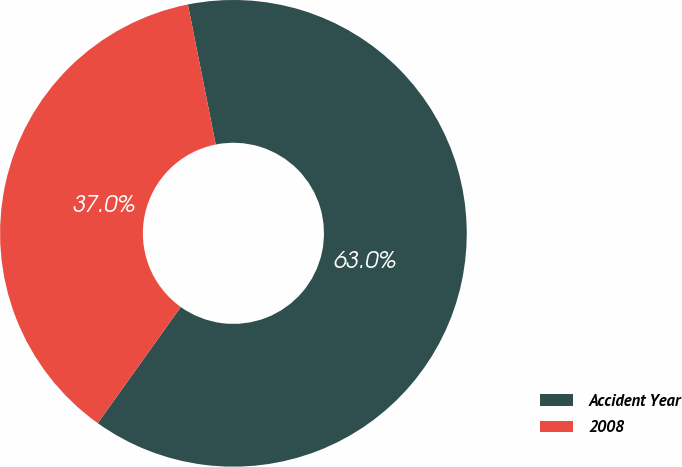Convert chart to OTSL. <chart><loc_0><loc_0><loc_500><loc_500><pie_chart><fcel>Accident Year<fcel>2008<nl><fcel>63.0%<fcel>37.0%<nl></chart> 